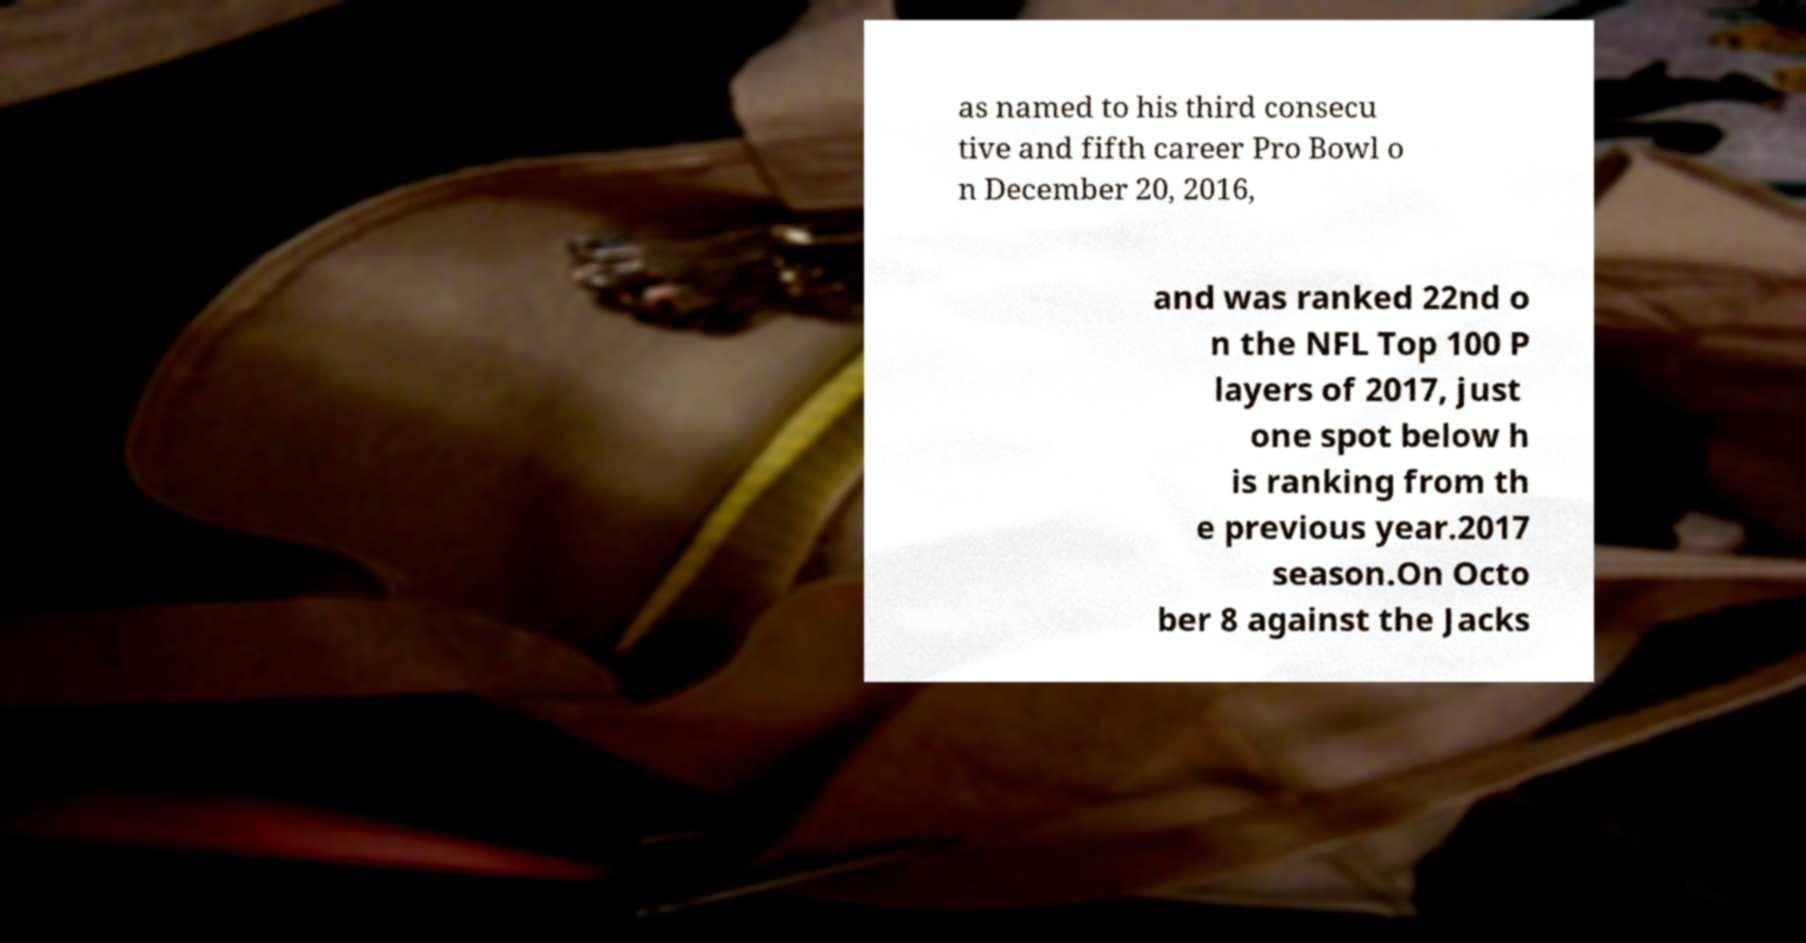Please read and relay the text visible in this image. What does it say? as named to his third consecu tive and fifth career Pro Bowl o n December 20, 2016, and was ranked 22nd o n the NFL Top 100 P layers of 2017, just one spot below h is ranking from th e previous year.2017 season.On Octo ber 8 against the Jacks 